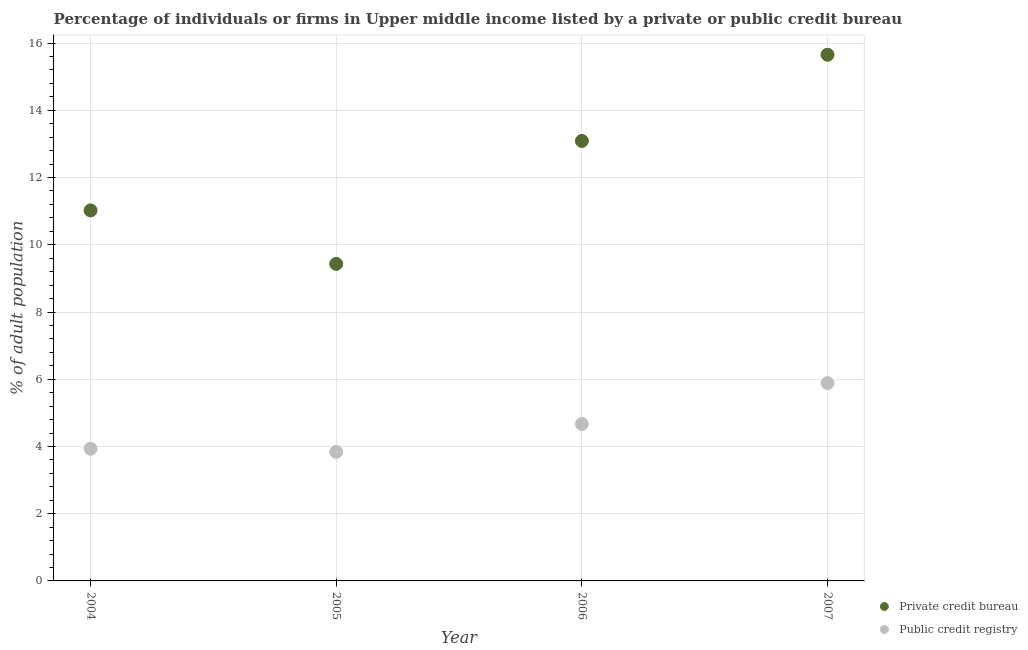Is the number of dotlines equal to the number of legend labels?
Give a very brief answer. Yes. What is the percentage of firms listed by public credit bureau in 2004?
Keep it short and to the point. 3.93. Across all years, what is the maximum percentage of firms listed by private credit bureau?
Your answer should be very brief. 15.65. Across all years, what is the minimum percentage of firms listed by private credit bureau?
Your response must be concise. 9.43. In which year was the percentage of firms listed by public credit bureau maximum?
Provide a short and direct response. 2007. What is the total percentage of firms listed by private credit bureau in the graph?
Provide a short and direct response. 49.2. What is the difference between the percentage of firms listed by public credit bureau in 2004 and that in 2005?
Keep it short and to the point. 0.09. What is the difference between the percentage of firms listed by public credit bureau in 2007 and the percentage of firms listed by private credit bureau in 2006?
Keep it short and to the point. -7.2. What is the average percentage of firms listed by public credit bureau per year?
Give a very brief answer. 4.58. In the year 2005, what is the difference between the percentage of firms listed by public credit bureau and percentage of firms listed by private credit bureau?
Your response must be concise. -5.59. In how many years, is the percentage of firms listed by private credit bureau greater than 4.4 %?
Your response must be concise. 4. What is the ratio of the percentage of firms listed by public credit bureau in 2005 to that in 2006?
Your answer should be compact. 0.82. Is the difference between the percentage of firms listed by private credit bureau in 2006 and 2007 greater than the difference between the percentage of firms listed by public credit bureau in 2006 and 2007?
Offer a very short reply. No. What is the difference between the highest and the second highest percentage of firms listed by public credit bureau?
Keep it short and to the point. 1.22. What is the difference between the highest and the lowest percentage of firms listed by private credit bureau?
Make the answer very short. 6.22. In how many years, is the percentage of firms listed by private credit bureau greater than the average percentage of firms listed by private credit bureau taken over all years?
Provide a succinct answer. 2. Is the sum of the percentage of firms listed by private credit bureau in 2005 and 2006 greater than the maximum percentage of firms listed by public credit bureau across all years?
Offer a terse response. Yes. Does the percentage of firms listed by private credit bureau monotonically increase over the years?
Your answer should be very brief. No. How many dotlines are there?
Offer a terse response. 2. What is the difference between two consecutive major ticks on the Y-axis?
Ensure brevity in your answer.  2. Does the graph contain any zero values?
Give a very brief answer. No. Where does the legend appear in the graph?
Offer a very short reply. Bottom right. How many legend labels are there?
Give a very brief answer. 2. What is the title of the graph?
Give a very brief answer. Percentage of individuals or firms in Upper middle income listed by a private or public credit bureau. What is the label or title of the X-axis?
Provide a short and direct response. Year. What is the label or title of the Y-axis?
Keep it short and to the point. % of adult population. What is the % of adult population of Private credit bureau in 2004?
Provide a short and direct response. 11.02. What is the % of adult population in Public credit registry in 2004?
Your response must be concise. 3.93. What is the % of adult population of Private credit bureau in 2005?
Your answer should be very brief. 9.43. What is the % of adult population of Public credit registry in 2005?
Your answer should be compact. 3.84. What is the % of adult population in Private credit bureau in 2006?
Offer a very short reply. 13.09. What is the % of adult population of Public credit registry in 2006?
Your answer should be compact. 4.67. What is the % of adult population in Private credit bureau in 2007?
Offer a very short reply. 15.65. What is the % of adult population in Public credit registry in 2007?
Keep it short and to the point. 5.89. Across all years, what is the maximum % of adult population in Private credit bureau?
Provide a short and direct response. 15.65. Across all years, what is the maximum % of adult population in Public credit registry?
Ensure brevity in your answer.  5.89. Across all years, what is the minimum % of adult population in Private credit bureau?
Ensure brevity in your answer.  9.43. Across all years, what is the minimum % of adult population in Public credit registry?
Ensure brevity in your answer.  3.84. What is the total % of adult population of Private credit bureau in the graph?
Give a very brief answer. 49.2. What is the total % of adult population of Public credit registry in the graph?
Provide a succinct answer. 18.33. What is the difference between the % of adult population of Private credit bureau in 2004 and that in 2005?
Make the answer very short. 1.59. What is the difference between the % of adult population of Public credit registry in 2004 and that in 2005?
Keep it short and to the point. 0.09. What is the difference between the % of adult population of Private credit bureau in 2004 and that in 2006?
Offer a terse response. -2.07. What is the difference between the % of adult population in Public credit registry in 2004 and that in 2006?
Make the answer very short. -0.74. What is the difference between the % of adult population of Private credit bureau in 2004 and that in 2007?
Provide a succinct answer. -4.63. What is the difference between the % of adult population in Public credit registry in 2004 and that in 2007?
Provide a short and direct response. -1.95. What is the difference between the % of adult population in Private credit bureau in 2005 and that in 2006?
Provide a succinct answer. -3.66. What is the difference between the % of adult population of Public credit registry in 2005 and that in 2006?
Provide a short and direct response. -0.83. What is the difference between the % of adult population in Private credit bureau in 2005 and that in 2007?
Provide a succinct answer. -6.22. What is the difference between the % of adult population of Public credit registry in 2005 and that in 2007?
Make the answer very short. -2.05. What is the difference between the % of adult population of Private credit bureau in 2006 and that in 2007?
Offer a terse response. -2.56. What is the difference between the % of adult population of Public credit registry in 2006 and that in 2007?
Keep it short and to the point. -1.22. What is the difference between the % of adult population of Private credit bureau in 2004 and the % of adult population of Public credit registry in 2005?
Provide a short and direct response. 7.18. What is the difference between the % of adult population of Private credit bureau in 2004 and the % of adult population of Public credit registry in 2006?
Your answer should be compact. 6.35. What is the difference between the % of adult population in Private credit bureau in 2004 and the % of adult population in Public credit registry in 2007?
Give a very brief answer. 5.13. What is the difference between the % of adult population in Private credit bureau in 2005 and the % of adult population in Public credit registry in 2006?
Give a very brief answer. 4.76. What is the difference between the % of adult population of Private credit bureau in 2005 and the % of adult population of Public credit registry in 2007?
Your response must be concise. 3.55. What is the difference between the % of adult population of Private credit bureau in 2006 and the % of adult population of Public credit registry in 2007?
Your answer should be very brief. 7.2. What is the average % of adult population in Private credit bureau per year?
Offer a terse response. 12.3. What is the average % of adult population in Public credit registry per year?
Your response must be concise. 4.58. In the year 2004, what is the difference between the % of adult population of Private credit bureau and % of adult population of Public credit registry?
Provide a succinct answer. 7.09. In the year 2005, what is the difference between the % of adult population in Private credit bureau and % of adult population in Public credit registry?
Make the answer very short. 5.59. In the year 2006, what is the difference between the % of adult population in Private credit bureau and % of adult population in Public credit registry?
Provide a short and direct response. 8.42. In the year 2007, what is the difference between the % of adult population in Private credit bureau and % of adult population in Public credit registry?
Offer a terse response. 9.77. What is the ratio of the % of adult population of Private credit bureau in 2004 to that in 2005?
Offer a very short reply. 1.17. What is the ratio of the % of adult population in Public credit registry in 2004 to that in 2005?
Your answer should be very brief. 1.02. What is the ratio of the % of adult population in Private credit bureau in 2004 to that in 2006?
Keep it short and to the point. 0.84. What is the ratio of the % of adult population in Public credit registry in 2004 to that in 2006?
Offer a very short reply. 0.84. What is the ratio of the % of adult population of Private credit bureau in 2004 to that in 2007?
Keep it short and to the point. 0.7. What is the ratio of the % of adult population in Public credit registry in 2004 to that in 2007?
Give a very brief answer. 0.67. What is the ratio of the % of adult population of Private credit bureau in 2005 to that in 2006?
Your response must be concise. 0.72. What is the ratio of the % of adult population in Public credit registry in 2005 to that in 2006?
Ensure brevity in your answer.  0.82. What is the ratio of the % of adult population in Private credit bureau in 2005 to that in 2007?
Provide a succinct answer. 0.6. What is the ratio of the % of adult population of Public credit registry in 2005 to that in 2007?
Your response must be concise. 0.65. What is the ratio of the % of adult population of Private credit bureau in 2006 to that in 2007?
Provide a short and direct response. 0.84. What is the ratio of the % of adult population of Public credit registry in 2006 to that in 2007?
Make the answer very short. 0.79. What is the difference between the highest and the second highest % of adult population in Private credit bureau?
Offer a very short reply. 2.56. What is the difference between the highest and the second highest % of adult population in Public credit registry?
Make the answer very short. 1.22. What is the difference between the highest and the lowest % of adult population in Private credit bureau?
Ensure brevity in your answer.  6.22. What is the difference between the highest and the lowest % of adult population in Public credit registry?
Give a very brief answer. 2.05. 